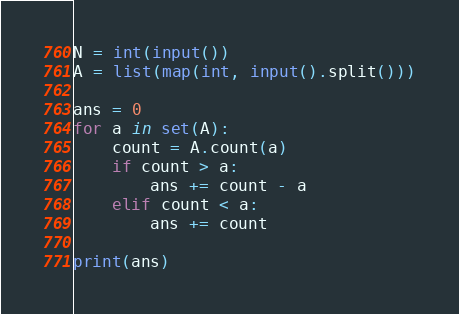Convert code to text. <code><loc_0><loc_0><loc_500><loc_500><_Python_>N = int(input())
A = list(map(int, input().split()))

ans = 0
for a in set(A):
    count = A.count(a)
    if count > a:
        ans += count - a
    elif count < a:
        ans += count

print(ans)

</code> 